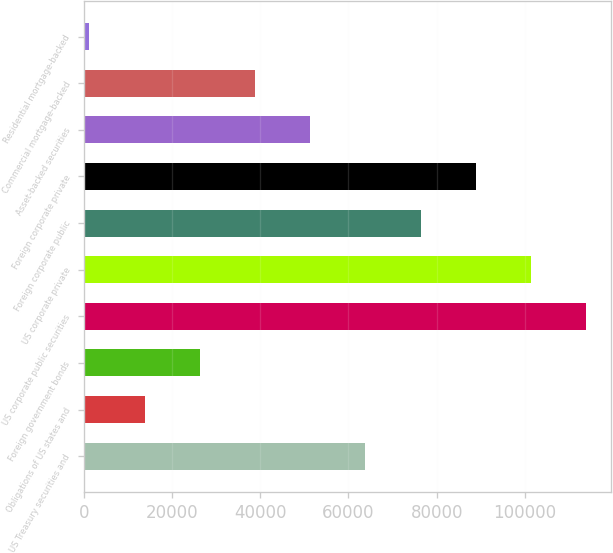Convert chart. <chart><loc_0><loc_0><loc_500><loc_500><bar_chart><fcel>US Treasury securities and<fcel>Obligations of US states and<fcel>Foreign government bonds<fcel>US corporate public securities<fcel>US corporate private<fcel>Foreign corporate public<fcel>Foreign corporate private<fcel>Asset-backed securities<fcel>Commercial mortgage-backed<fcel>Residential mortgage-backed<nl><fcel>63852.5<fcel>13759.3<fcel>26282.6<fcel>113946<fcel>101422<fcel>76375.8<fcel>88899.1<fcel>51329.2<fcel>38805.9<fcel>1236<nl></chart> 